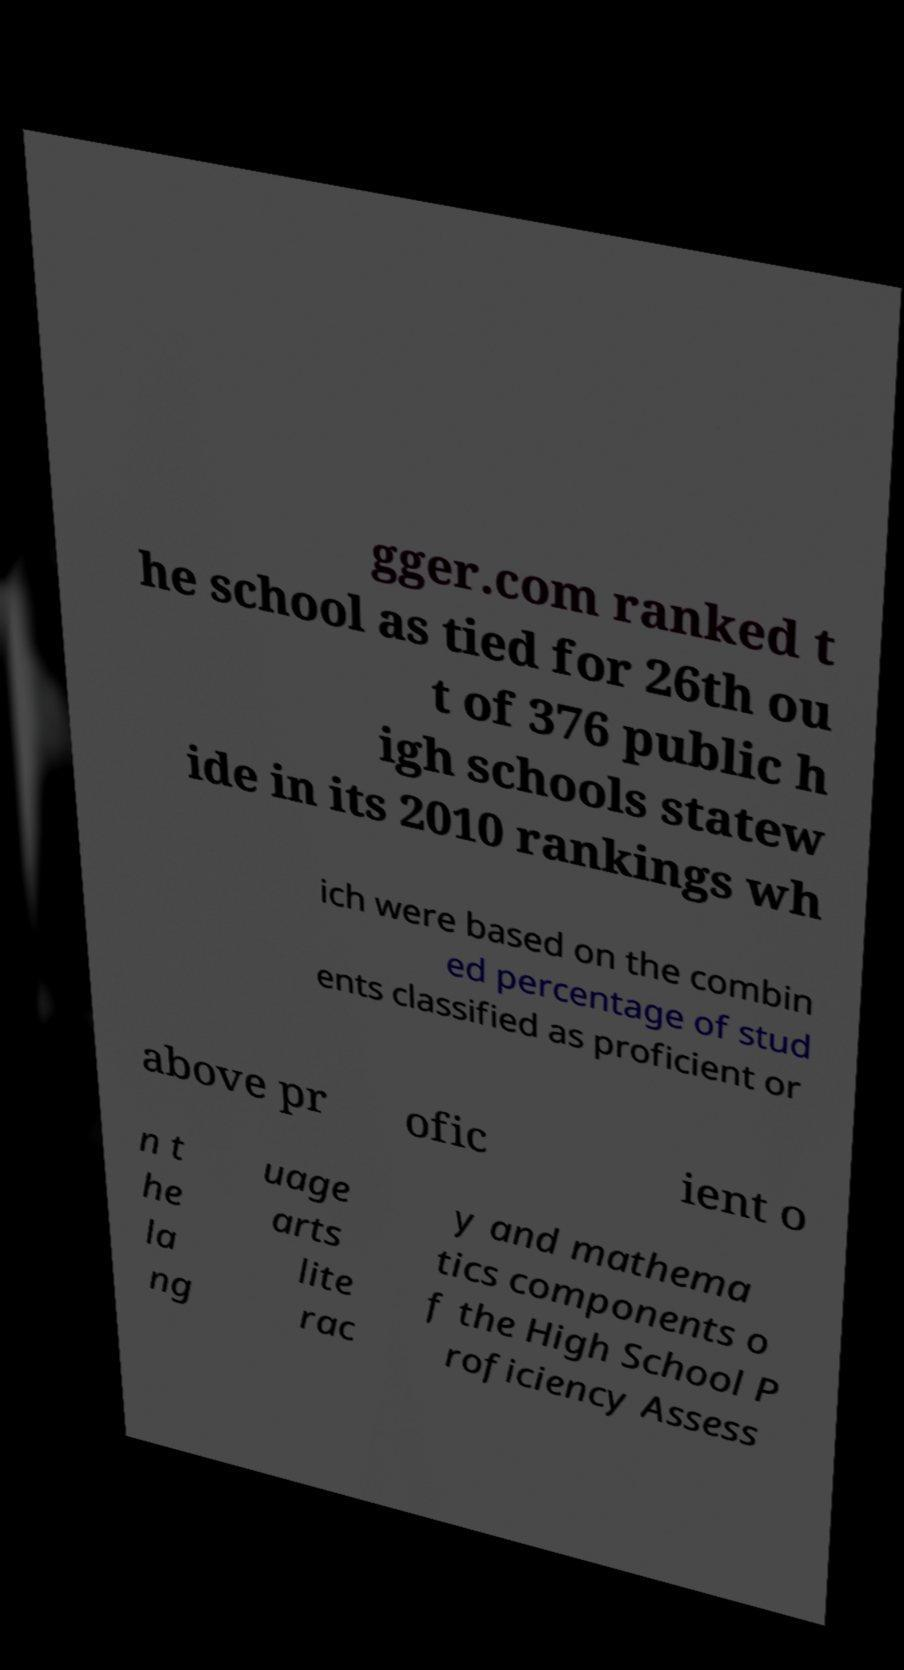There's text embedded in this image that I need extracted. Can you transcribe it verbatim? gger.com ranked t he school as tied for 26th ou t of 376 public h igh schools statew ide in its 2010 rankings wh ich were based on the combin ed percentage of stud ents classified as proficient or above pr ofic ient o n t he la ng uage arts lite rac y and mathema tics components o f the High School P roficiency Assess 